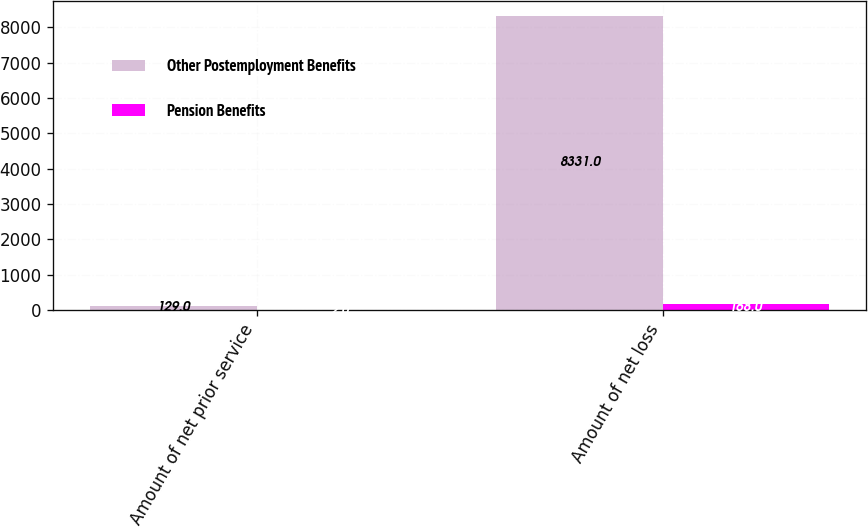Convert chart to OTSL. <chart><loc_0><loc_0><loc_500><loc_500><stacked_bar_chart><ecel><fcel>Amount of net prior service<fcel>Amount of net loss<nl><fcel>Other Postemployment Benefits<fcel>129<fcel>8331<nl><fcel>Pension Benefits<fcel>2<fcel>168<nl></chart> 